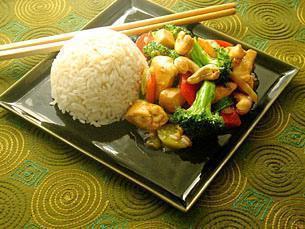What utensil will the food be eaten with?
Answer the question by selecting the correct answer among the 4 following choices and explain your choice with a short sentence. The answer should be formatted with the following format: `Answer: choice
Rationale: rationale.`
Options: Chopstick, knife, spoon, fork. Answer: chopstick.
Rationale: The utensils are visible on the plate and are the size, color and shape of answer a. 